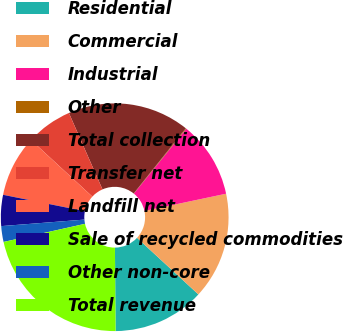<chart> <loc_0><loc_0><loc_500><loc_500><pie_chart><fcel>Residential<fcel>Commercial<fcel>Industrial<fcel>Other<fcel>Total collection<fcel>Transfer net<fcel>Landfill net<fcel>Sale of recycled commodities<fcel>Other non-core<fcel>Total revenue<nl><fcel>13.02%<fcel>15.17%<fcel>10.86%<fcel>0.09%<fcel>17.33%<fcel>6.55%<fcel>8.71%<fcel>4.4%<fcel>2.24%<fcel>21.64%<nl></chart> 